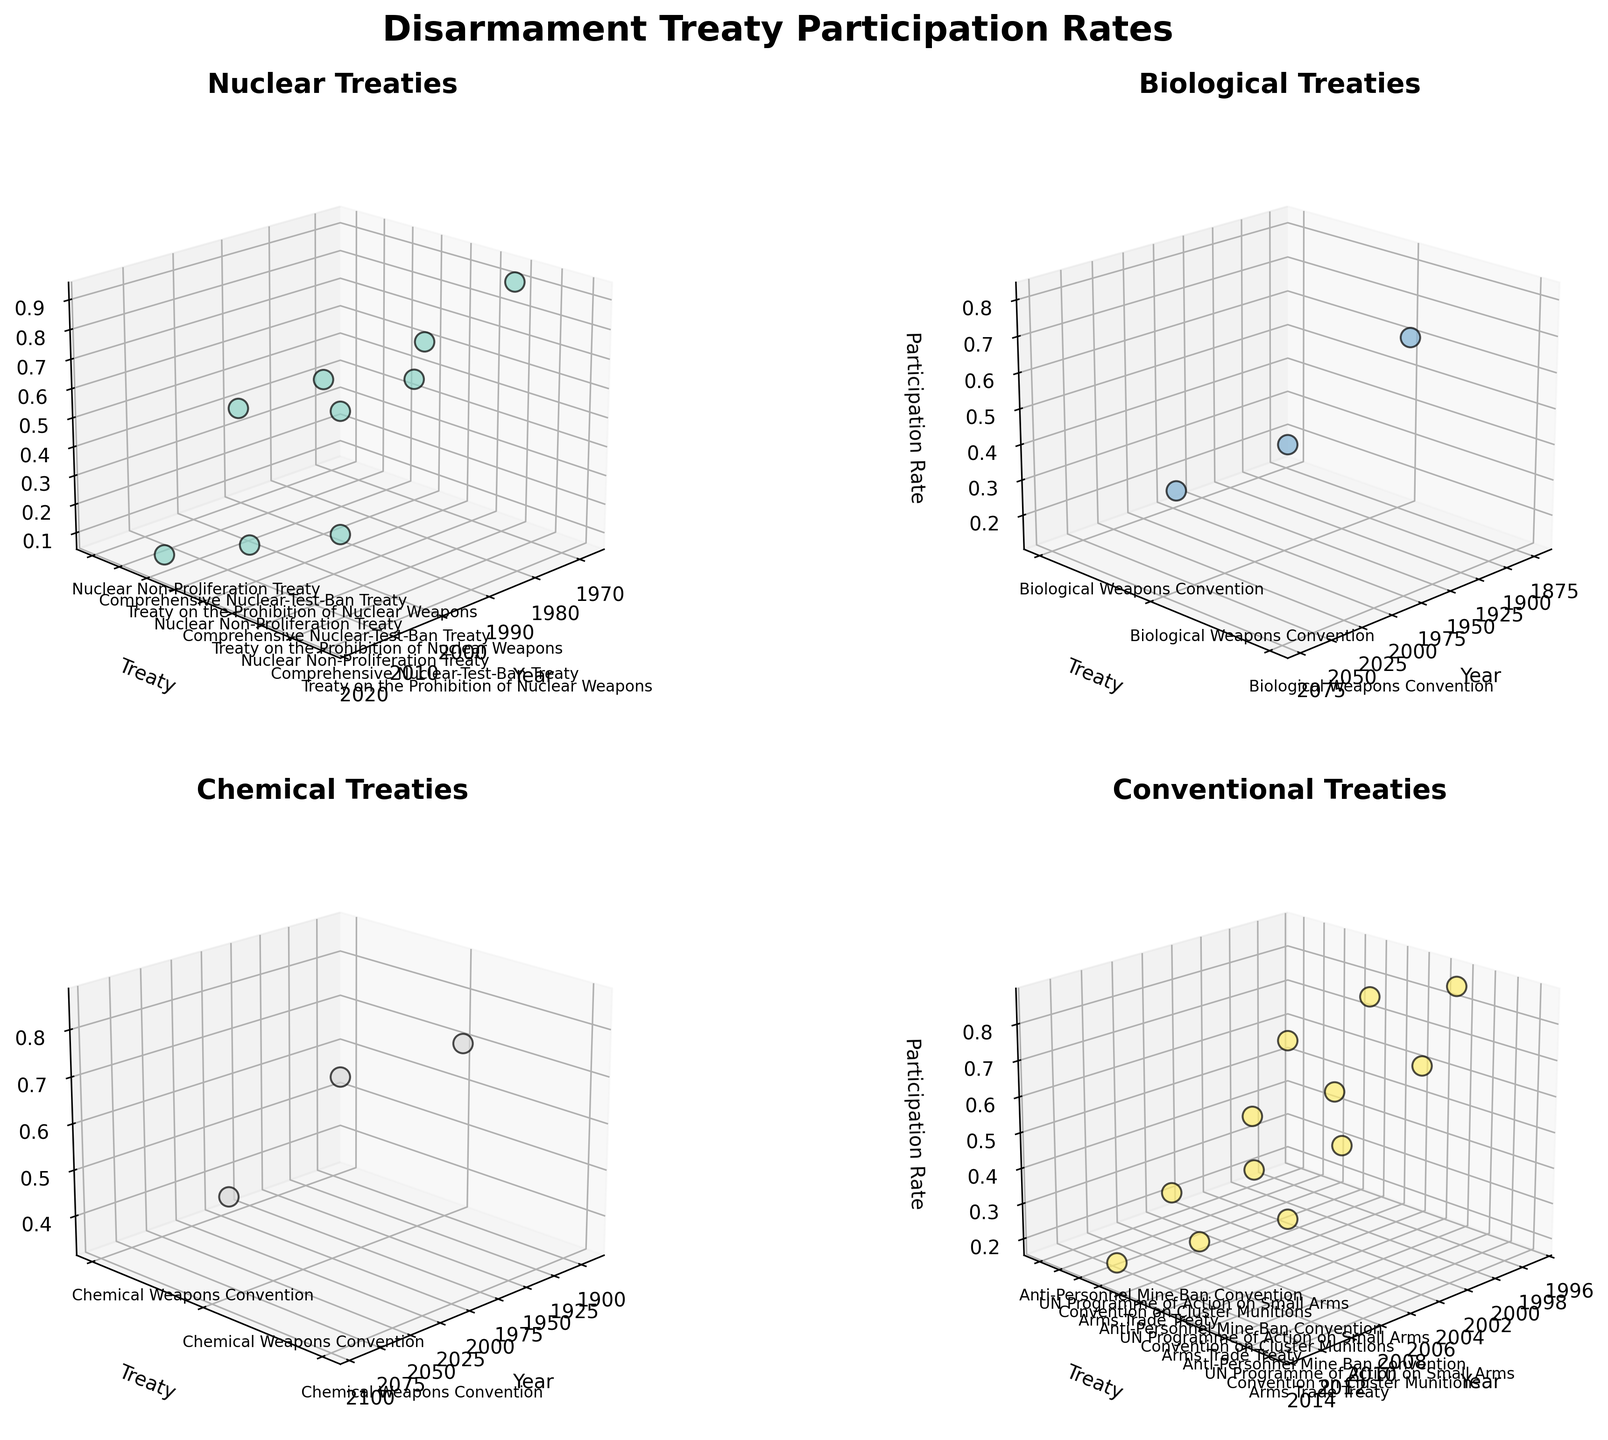What is the title of each subplot? You can see the title at the top of each subplot. The titles are related to different types of treaties: Nuclear, Biological, Chemical, and Conventional.
Answer: Nuclear Treaties, Biological Treaties, Chemical Treaties, Conventional Treaties Approximately how many treaties are shown in the subplot for Conventional Treaties? By counting the y-axis labels for the subplot titled "Conventional Treaties," which represents each treaty name, you can determine the number of treaties.
Answer: 4 Which treaty type has the highest participation rate for the latest year shown in the data? By examining the plots, you need to find the subplot with the highest z-value (Participation Rate) for the latest year on the x-axis. In this case, the Nuclear Treaties subplot for the 2017 Treaty on the Prohibition of Nuclear Weapons has a higher rate than any other treaty types shown for 2017.
Answer: Nuclear Between the Nuclear Non-Proliferation Treaty and the Treaty on the Prohibition of Nuclear Weapons, which has a higher participation rate in 2017? By locating both treaties in the "Nuclear Treaties" subplot and comparing their z-values (Participation Rates) for 2017, you can see the difference.
Answer: Treaty on the Prohibition of Nuclear Weapons Which treaty has the lowest participation rate in the year 1993? Check the z-values (Participation Rates) for all subplots for the year 1993 and compare them.
Answer: Chemical Weapons Convention How does the participation rate of the Chemical Weapons Convention in 1993 compare to the Comprehensive Nuclear-Test-Ban Treaty in 1996? Look at the z-values for the two mentioned treaties in the respective years in their subplots and compare.
Answer: Chemical Weapons Convention in 1993 is higher What is the average participation rate of all Biological Treaties observed in the data? First, identify the participation rates for all Biological Treaties. Then, sum these rates and divide by the number of treaties to find the average.
Answer: (0.15+0.40+0.80)/3 ≈ 0.45 Which Conventional treaty shows a declining trend in participation rate over the years? Locate all Conventional treaties in the "Conventional Treaties" subplot and observe the direction of the z-values (Participation Rates) across years.
Answer: Arms Trade Treaty What is the range of years represented in the Biological Treaties subplot? By examining the x-axis values in the "Biological Treaties" subplot, you can see the earliest and latest years.
Answer: 1972-1972 Compare the variation in Participation Rates among Chemical and Biological Treaties. Which has a greater range? Calculate the range of z-values (Participation Rates) for both "Chemical Treaties" and "Biological Treaties" subplots. The range is the difference between the maximum and the minimum Participation Rate within each treaty type.
Answer: Chemical Treaties 